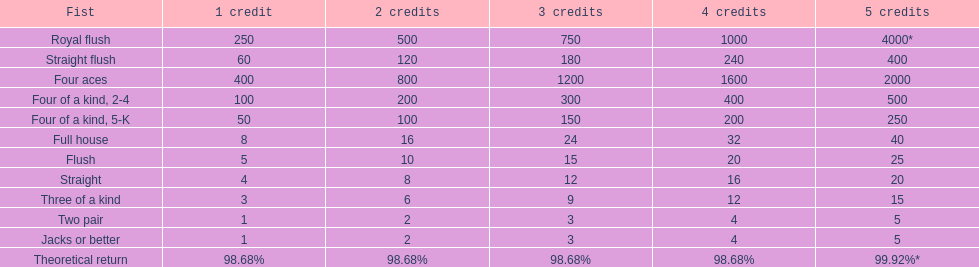Every four aces victory is a multiple of which number? 400. 